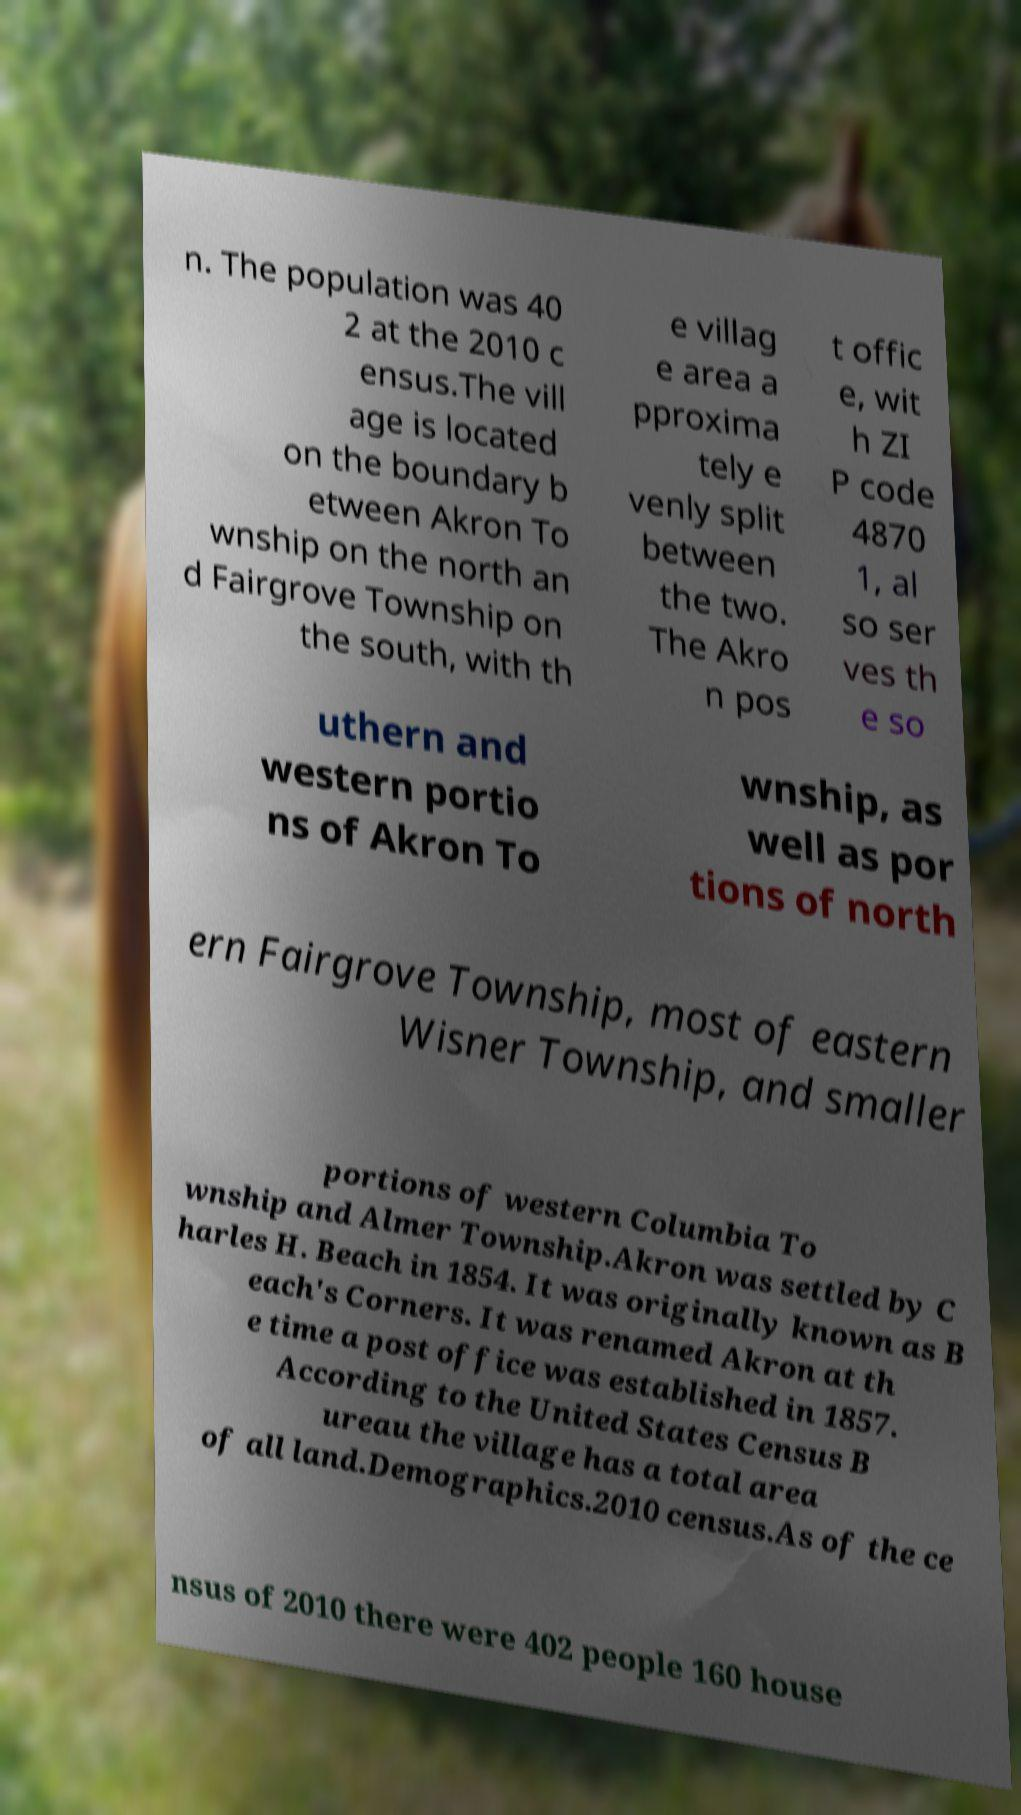Please identify and transcribe the text found in this image. n. The population was 40 2 at the 2010 c ensus.The vill age is located on the boundary b etween Akron To wnship on the north an d Fairgrove Township on the south, with th e villag e area a pproxima tely e venly split between the two. The Akro n pos t offic e, wit h ZI P code 4870 1, al so ser ves th e so uthern and western portio ns of Akron To wnship, as well as por tions of north ern Fairgrove Township, most of eastern Wisner Township, and smaller portions of western Columbia To wnship and Almer Township.Akron was settled by C harles H. Beach in 1854. It was originally known as B each's Corners. It was renamed Akron at th e time a post office was established in 1857. According to the United States Census B ureau the village has a total area of all land.Demographics.2010 census.As of the ce nsus of 2010 there were 402 people 160 house 